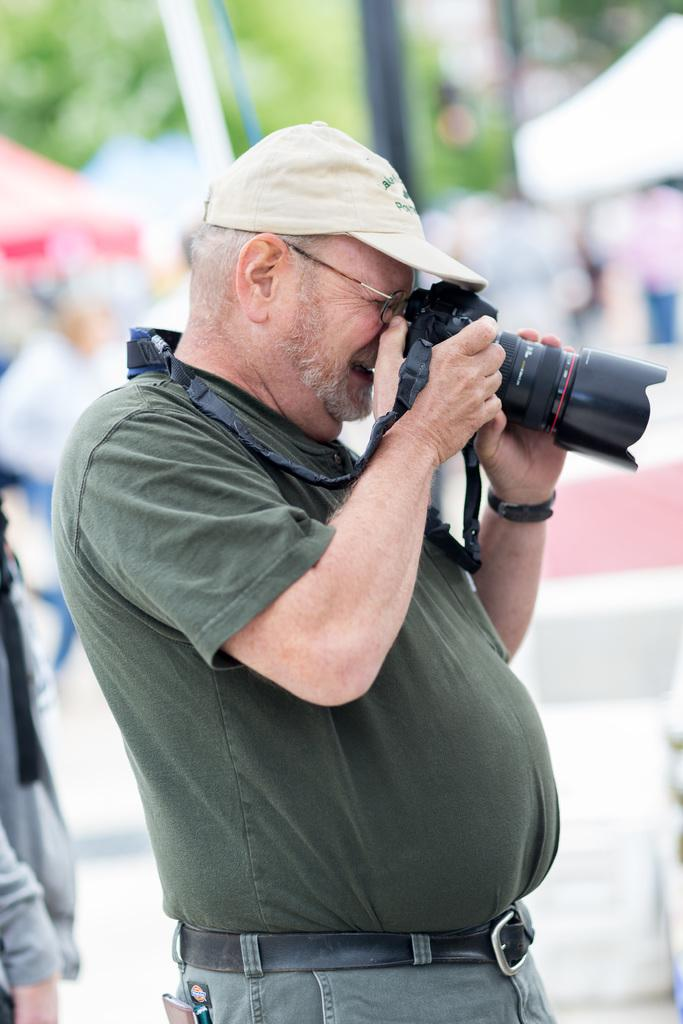What is the person in the image doing? The person in the image is using a camera. What can be seen in the background of the image? There are trees, poles, tents, and other persons in the background of the image. Can you describe the setting of the image? The image appears to be taken outdoors, with trees and tents in the background, suggesting a possible camping or outdoor event. What type of alley can be seen in the image? There is no alley present in the image. 